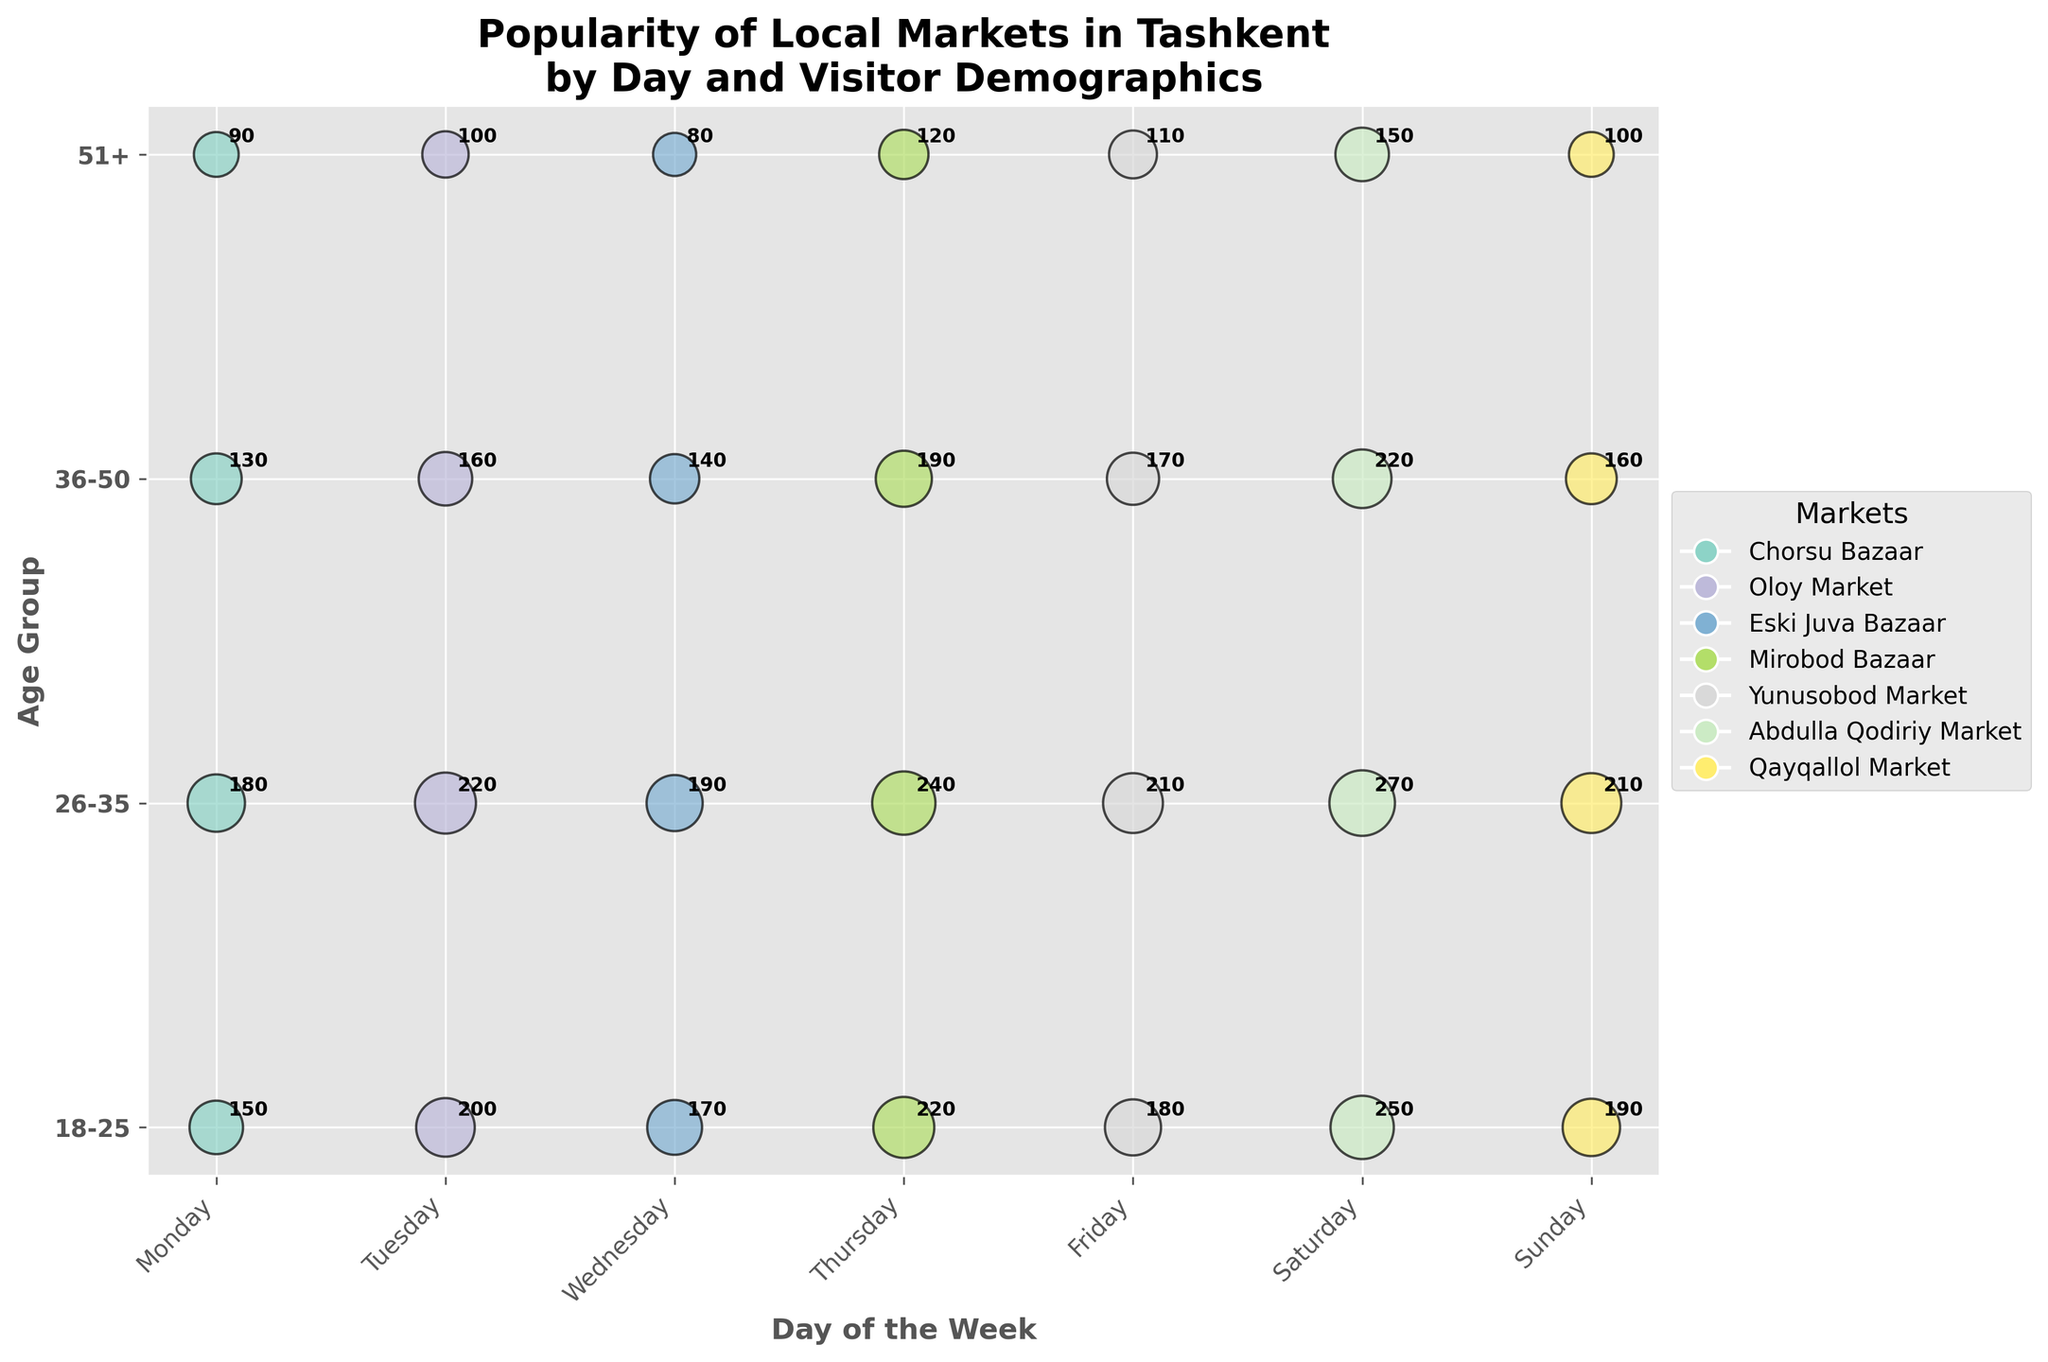What's the title of the chart? The title is located at the top of the chart and is generally easy to spot.
Answer: Popularity of Local Markets in Tashkent by Day and Visitor Demographics Which market has the highest average number of visitors on Thursday? To answer this, look at the bubble sizes and annotations on Thursday. Mirobod Bazaar has the highest numbers highlighted with bubbles of sizes 130, 140, 110, and 85, and annotations with 220, 240, 190, and 120 visitors respectively.
Answer: Mirobod Bazaar Which age group has the most visitors in Abdulla Qodiriy Market on Saturday? Look at Abdulla Qodiriy Market on Saturday to see the age groups and their respective visitor counts: 18-25 (250), 26-35 (270), 36-50 (220), and 51+ (150). The age group 26-35 has the most visitors.
Answer: 26-35 What day has the lowest average visitors for Chorsu Bazaar? Examine the data for Chorsu Bazaar: Monday, where the 18-25 group has 150 visitors, the 26-35 group has 180, the 36-50 group has 130, and the 51+ group has 90. The lowest average visitors is in the 51+ group on Monday.
Answer: Monday What is the total number of average visitors in Qayqallol Market on Sunday? Sum the number of visitors for all age groups in Qayqallol Market on Sunday: 18-25 (190), 26-35 (210), 36-50 (160), and 51+ (100). Thus, 190 + 210 + 160 + 100 = 660.
Answer: 660 How does the number of visitors in the 51+ age group compare between Mirobod Bazaar on Thursday and Qayqallol Market on Sunday? The number of visitors in the 51+ age group are 120 for Mirobod Bazaar on Thursday and 100 for Qayqallol Market on Sunday. Thus, Mirobod Bazaar has more visitors in this age group.
Answer: Mirobod Bazaar Which market is the most popular among the 18-25 age group on any given day? Check the markets for the 18-25 age group, looking at the visitors' numbers: Chorsu Bazaar (150), Oloy Market (200), Eski Juva Bazaar (170), Mirobod Bazaar (220), Yunusobod Market (180), Abdulla Qodiriy Market (250), Qayqallol Market (190). Abdulla Qodiriy Market on Saturday has the highest with 250 visitors.
Answer: Abdulla Qodiriy Market On which day does Eski Juva Bazaar receive the highest average number of visitors? Eski Juva Bazaar data includes visitors from Wednesday: 18-25 (170), 26-35 (190), 36-50 (140), and 51+ (80). Since there is only one day, Wednesday has the highest average number of visitors for Eski Juva Bazaar.
Answer: Wednesday 